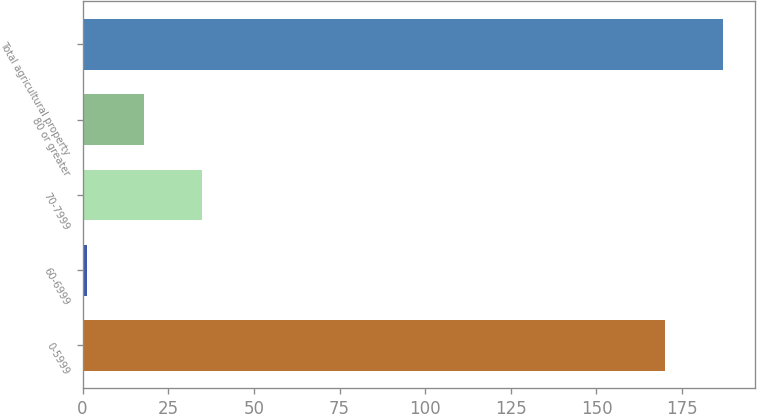<chart> <loc_0><loc_0><loc_500><loc_500><bar_chart><fcel>0-5999<fcel>60-6999<fcel>70-7999<fcel>80 or greater<fcel>Total agricultural property<nl><fcel>170<fcel>1.14<fcel>34.92<fcel>18.03<fcel>186.89<nl></chart> 